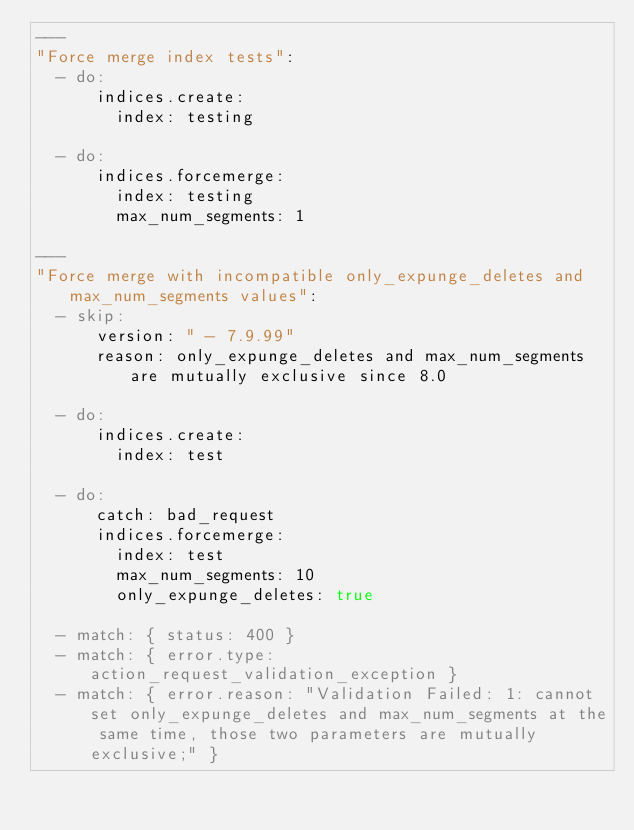Convert code to text. <code><loc_0><loc_0><loc_500><loc_500><_YAML_>---
"Force merge index tests":
  - do:
      indices.create:
        index: testing

  - do:
      indices.forcemerge:
        index: testing
        max_num_segments: 1

---
"Force merge with incompatible only_expunge_deletes and max_num_segments values":
  - skip:
      version: " - 7.9.99"
      reason: only_expunge_deletes and max_num_segments are mutually exclusive since 8.0

  - do:
      indices.create:
        index: test

  - do:
      catch: bad_request
      indices.forcemerge:
        index: test
        max_num_segments: 10
        only_expunge_deletes: true

  - match: { status: 400 }
  - match: { error.type: action_request_validation_exception }
  - match: { error.reason: "Validation Failed: 1: cannot set only_expunge_deletes and max_num_segments at the same time, those two parameters are mutually exclusive;" }
</code> 